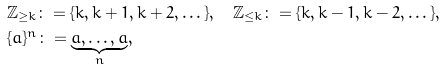<formula> <loc_0><loc_0><loc_500><loc_500>& \mathbb { Z } _ { \geq { k } } \colon = \{ k , k + 1 , k + 2 , \dots \} , \quad \mathbb { Z } _ { \leq { k } } \colon = \{ k , k - 1 , k - 2 , \dots \} , \\ & \{ a \} ^ { n } \colon = \underbrace { a , \dots , a } _ { n } ,</formula> 